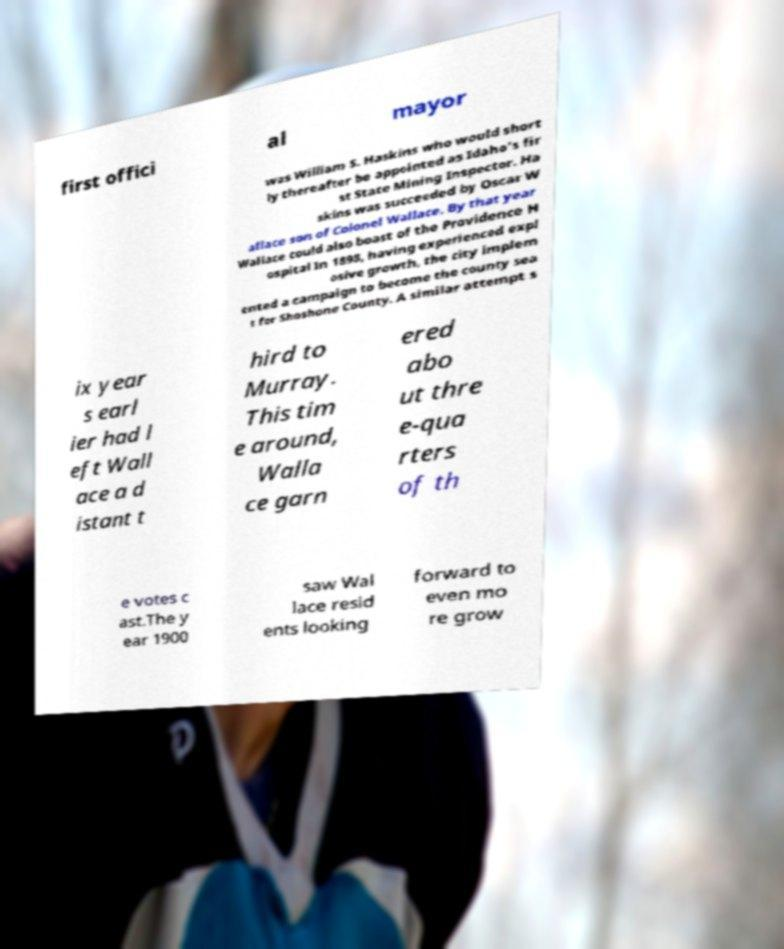For documentation purposes, I need the text within this image transcribed. Could you provide that? first offici al mayor was William S. Haskins who would short ly thereafter be appointed as Idaho's fir st State Mining Inspector. Ha skins was succeeded by Oscar W allace son of Colonel Wallace. By that year Wallace could also boast of the Providence H ospital In 1898, having experienced expl osive growth, the city implem ented a campaign to become the county sea t for Shoshone County. A similar attempt s ix year s earl ier had l eft Wall ace a d istant t hird to Murray. This tim e around, Walla ce garn ered abo ut thre e-qua rters of th e votes c ast.The y ear 1900 saw Wal lace resid ents looking forward to even mo re grow 